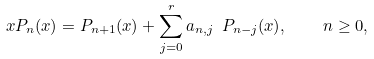Convert formula to latex. <formula><loc_0><loc_0><loc_500><loc_500>x P _ { n } ( x ) = P _ { n + 1 } ( x ) + \sum _ { j = 0 } ^ { r } a _ { n , j } \ P _ { n - j } ( x ) , \quad n \geq 0 ,</formula> 